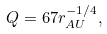<formula> <loc_0><loc_0><loc_500><loc_500>Q = 6 7 r _ { A U } ^ { - 1 / 4 } ,</formula> 